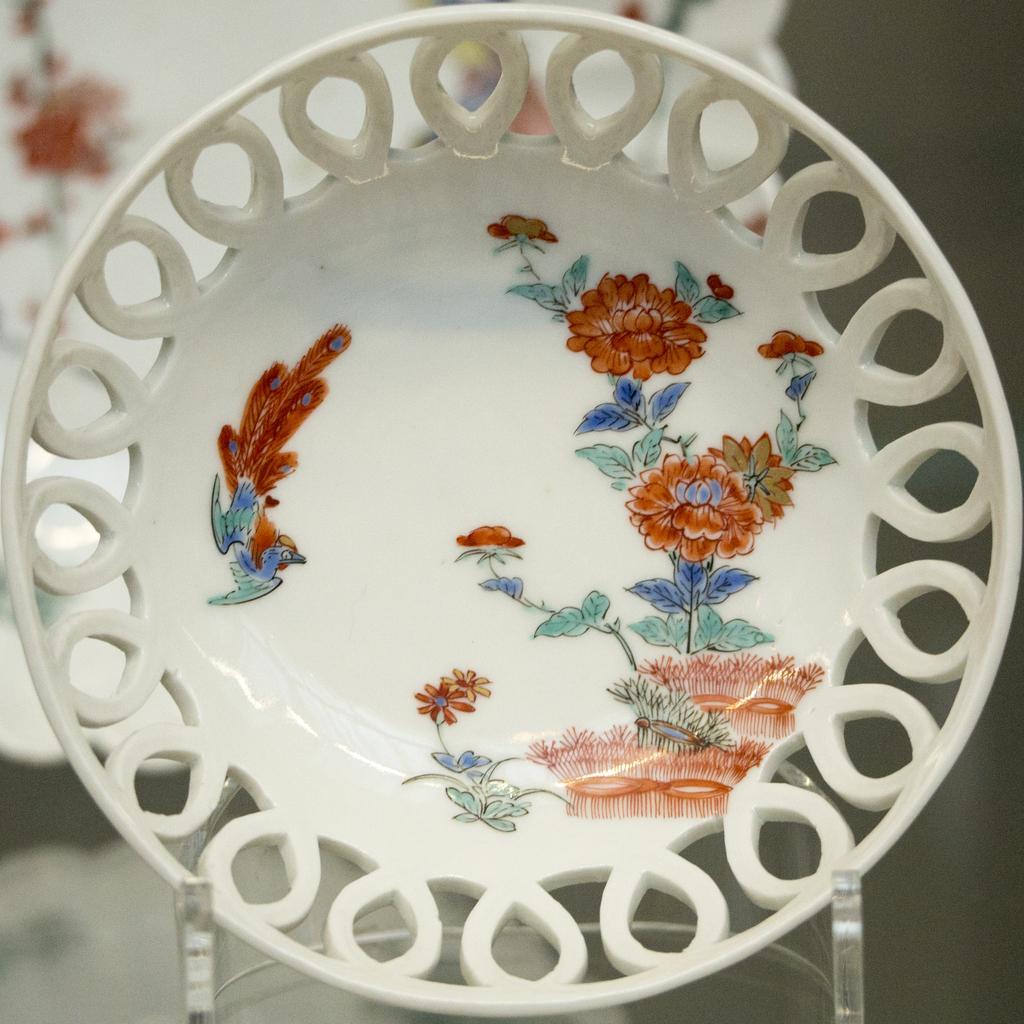Can you describe this image briefly? In this image I can see a plate which is on stand. It is in white,green,brown,blue color. Background is blurred. 